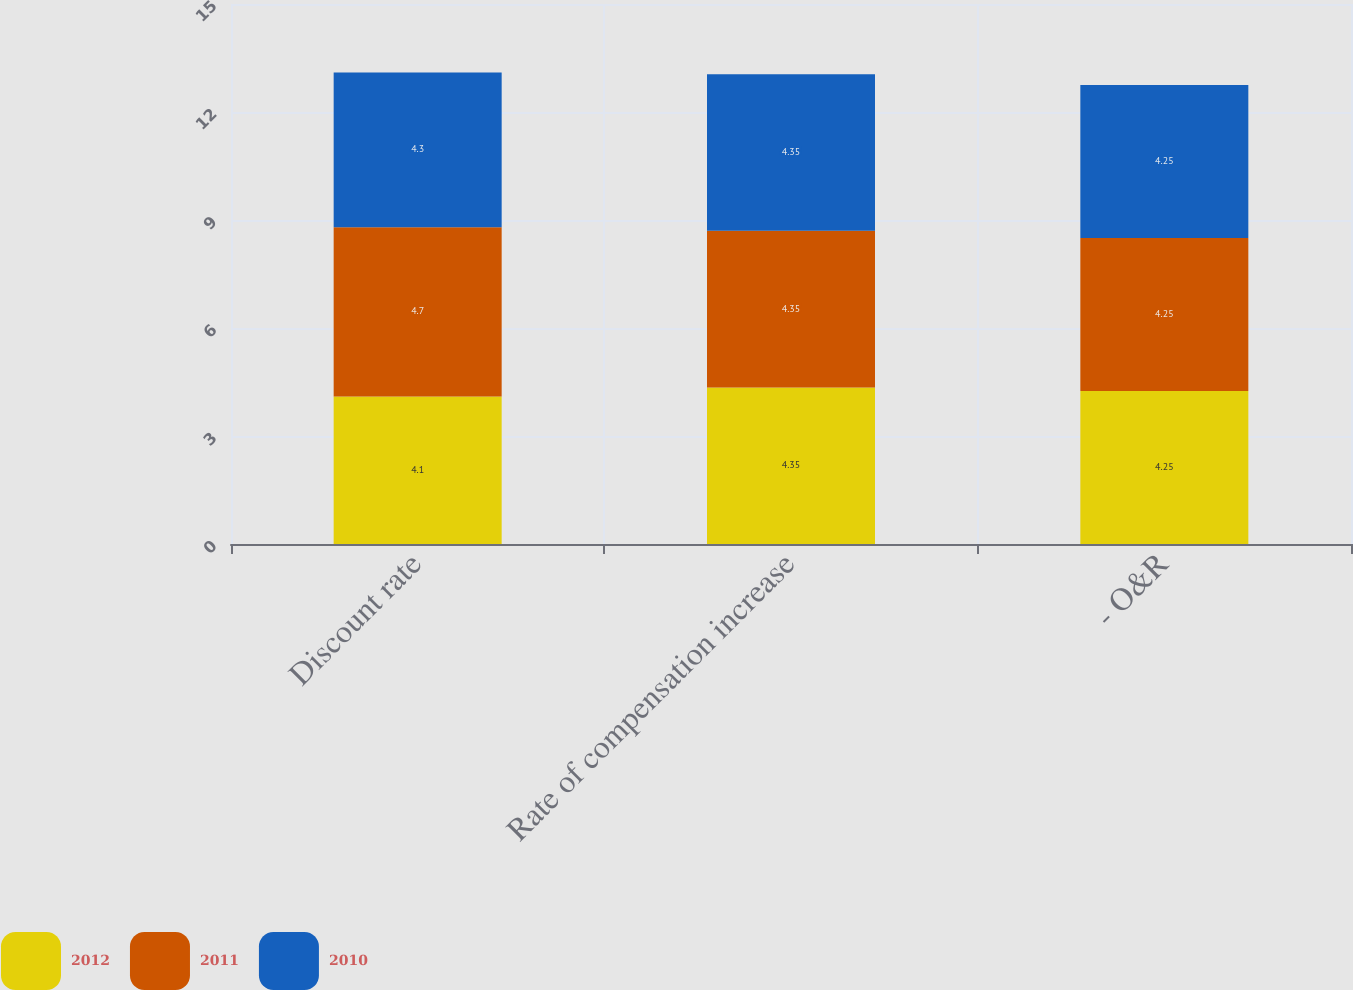<chart> <loc_0><loc_0><loc_500><loc_500><stacked_bar_chart><ecel><fcel>Discount rate<fcel>Rate of compensation increase<fcel>- O&R<nl><fcel>2012<fcel>4.1<fcel>4.35<fcel>4.25<nl><fcel>2011<fcel>4.7<fcel>4.35<fcel>4.25<nl><fcel>2010<fcel>4.3<fcel>4.35<fcel>4.25<nl></chart> 